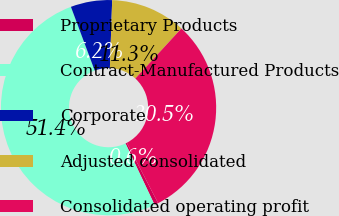Convert chart. <chart><loc_0><loc_0><loc_500><loc_500><pie_chart><fcel>Proprietary Products<fcel>Contract-Manufactured Products<fcel>Corporate<fcel>Adjusted consolidated<fcel>Consolidated operating profit<nl><fcel>0.58%<fcel>51.35%<fcel>6.22%<fcel>11.3%<fcel>30.54%<nl></chart> 